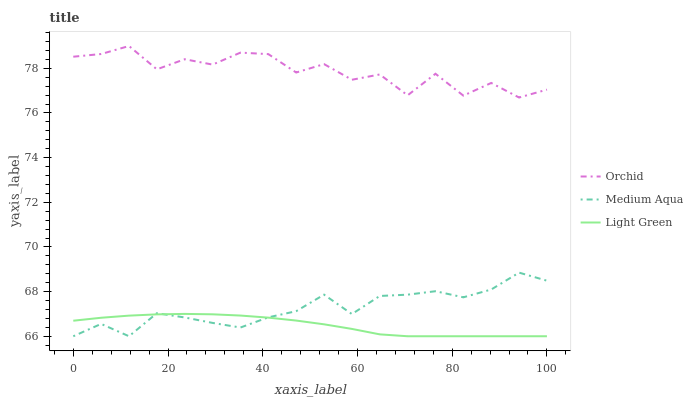Does Light Green have the minimum area under the curve?
Answer yes or no. Yes. Does Orchid have the maximum area under the curve?
Answer yes or no. Yes. Does Orchid have the minimum area under the curve?
Answer yes or no. No. Does Light Green have the maximum area under the curve?
Answer yes or no. No. Is Light Green the smoothest?
Answer yes or no. Yes. Is Orchid the roughest?
Answer yes or no. Yes. Is Orchid the smoothest?
Answer yes or no. No. Is Light Green the roughest?
Answer yes or no. No. Does Medium Aqua have the lowest value?
Answer yes or no. Yes. Does Orchid have the lowest value?
Answer yes or no. No. Does Orchid have the highest value?
Answer yes or no. Yes. Does Light Green have the highest value?
Answer yes or no. No. Is Light Green less than Orchid?
Answer yes or no. Yes. Is Orchid greater than Medium Aqua?
Answer yes or no. Yes. Does Light Green intersect Medium Aqua?
Answer yes or no. Yes. Is Light Green less than Medium Aqua?
Answer yes or no. No. Is Light Green greater than Medium Aqua?
Answer yes or no. No. Does Light Green intersect Orchid?
Answer yes or no. No. 